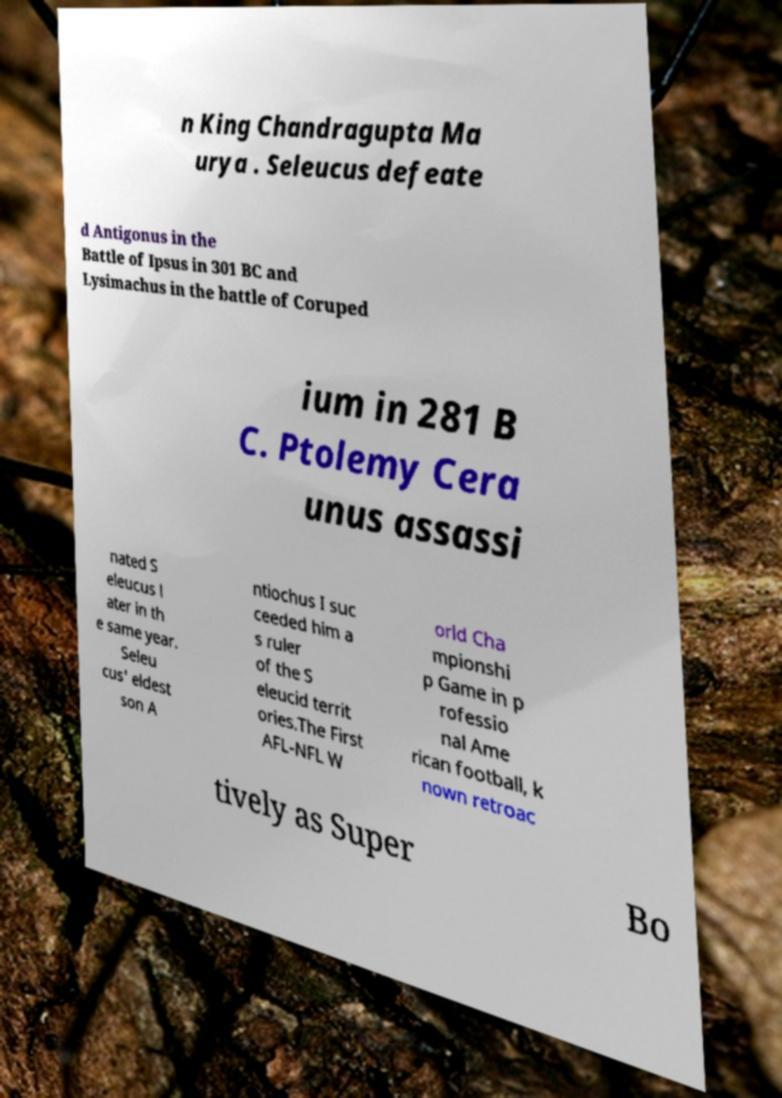Could you assist in decoding the text presented in this image and type it out clearly? n King Chandragupta Ma urya . Seleucus defeate d Antigonus in the Battle of Ipsus in 301 BC and Lysimachus in the battle of Coruped ium in 281 B C. Ptolemy Cera unus assassi nated S eleucus l ater in th e same year. Seleu cus' eldest son A ntiochus I suc ceeded him a s ruler of the S eleucid territ ories.The First AFL-NFL W orld Cha mpionshi p Game in p rofessio nal Ame rican football, k nown retroac tively as Super Bo 